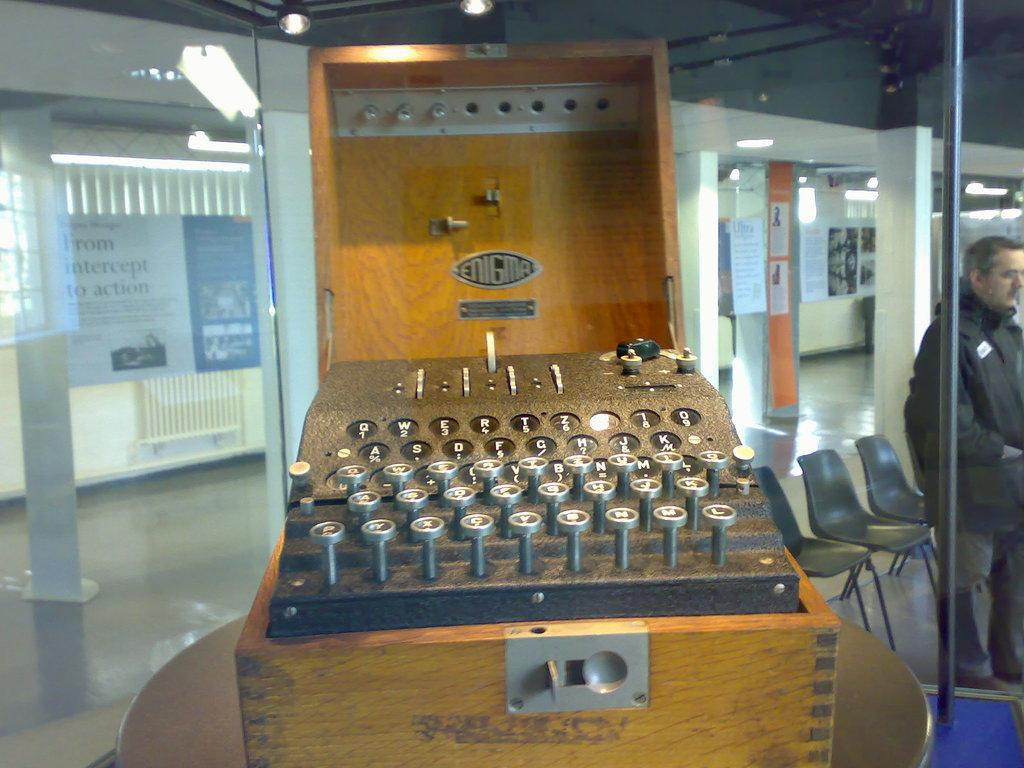<image>
Create a compact narrative representing the image presented. An old device from Enigma is in a glass display 